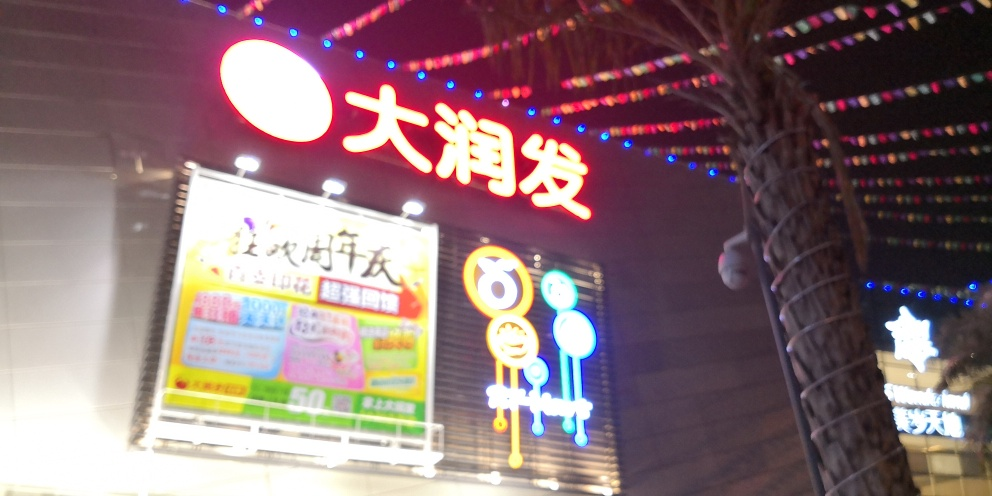Can you describe the overall mood or atmosphere that this image evokes? The image conveys a vibrant and dynamic mood, with bright neon lights and signs that are often associated with lively urban nightlife or commercial activity. 